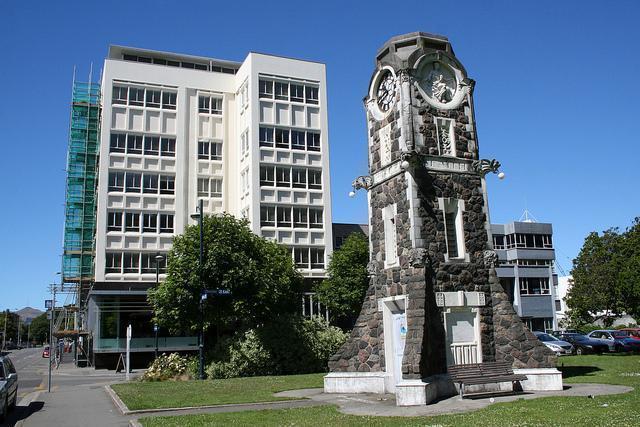How do you know there is work being done on the white building?
Answer the question by selecting the correct answer among the 4 following choices.
Options: Construction workers, signs, materials, scaffolding. Scaffolding. 